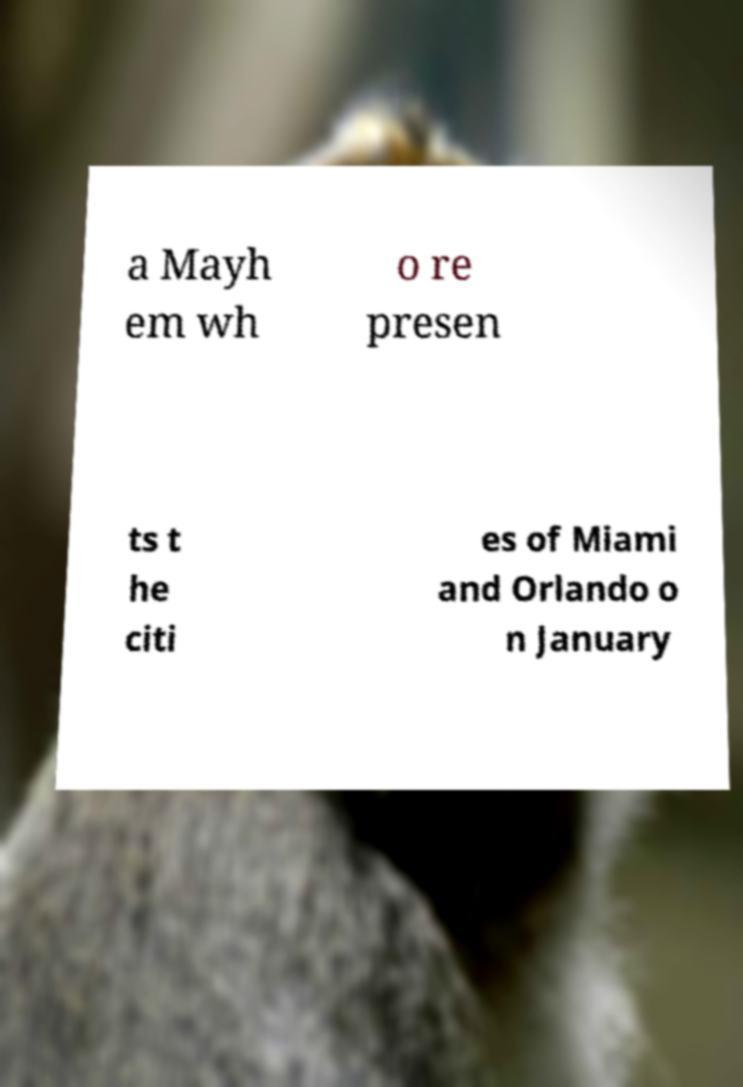Can you read and provide the text displayed in the image?This photo seems to have some interesting text. Can you extract and type it out for me? a Mayh em wh o re presen ts t he citi es of Miami and Orlando o n January 